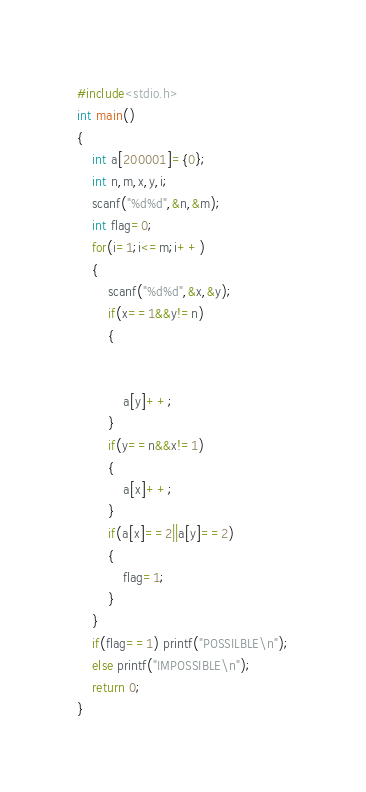Convert code to text. <code><loc_0><loc_0><loc_500><loc_500><_C_>#include<stdio.h>
int main()
{
	int a[200001]={0};
	int n,m,x,y,i;
	scanf("%d%d",&n,&m);
	int flag=0;
	for(i=1;i<=m;i++)
	{
		scanf("%d%d",&x,&y);
		if(x==1&&y!=n)
		{
			
			
			a[y]++;
		}
		if(y==n&&x!=1)
		{
			a[x]++;
		}
		if(a[x]==2||a[y]==2)
		{
			flag=1;
		}
	}
	if(flag==1) printf("POSSILBLE\n");
	else printf("IMPOSSIBLE\n");
	return 0;
} </code> 